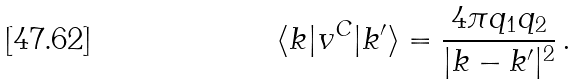<formula> <loc_0><loc_0><loc_500><loc_500>\langle { k } | v ^ { C } | { k } ^ { \prime } \rangle = \frac { 4 \pi q _ { 1 } q _ { 2 } } { | { k } - { k } ^ { \prime } | ^ { 2 } } \, .</formula> 